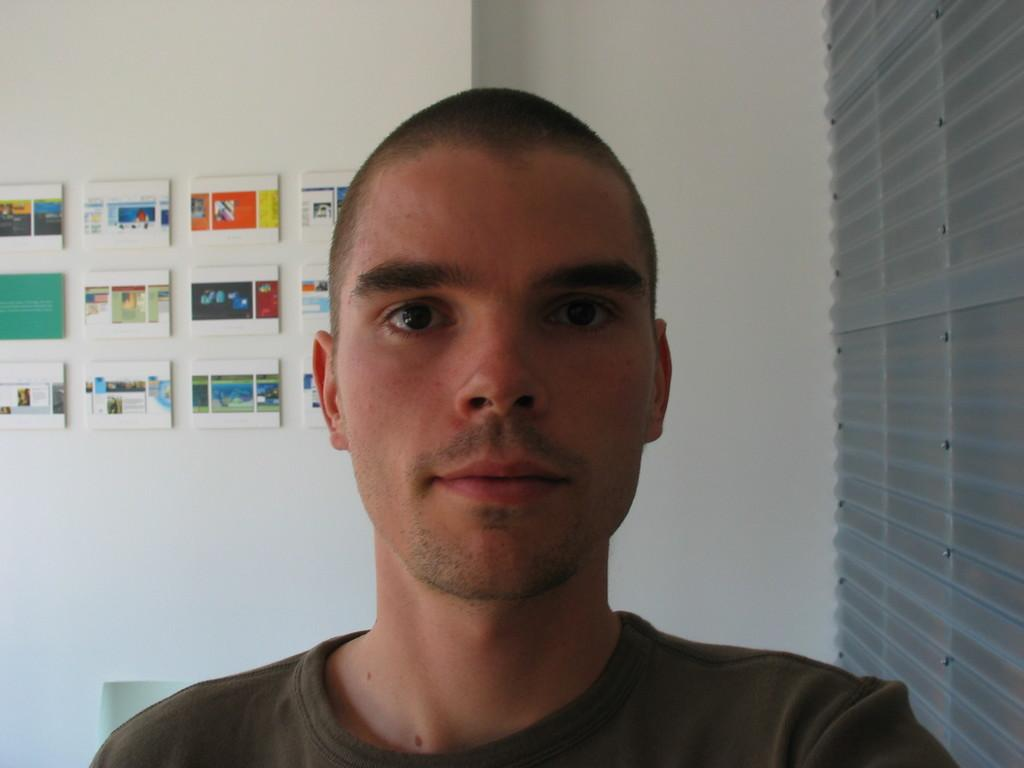Who is present in the image? There is a man in the image. What is behind the man? There is a wall behind the man. What is attached to the wall? There are boards on the wall. What can be seen to the right of the man? There are window blinds to the right of the man. How many boys are playing with the cat in the room? There is no room, cat, or boys present in the image. 